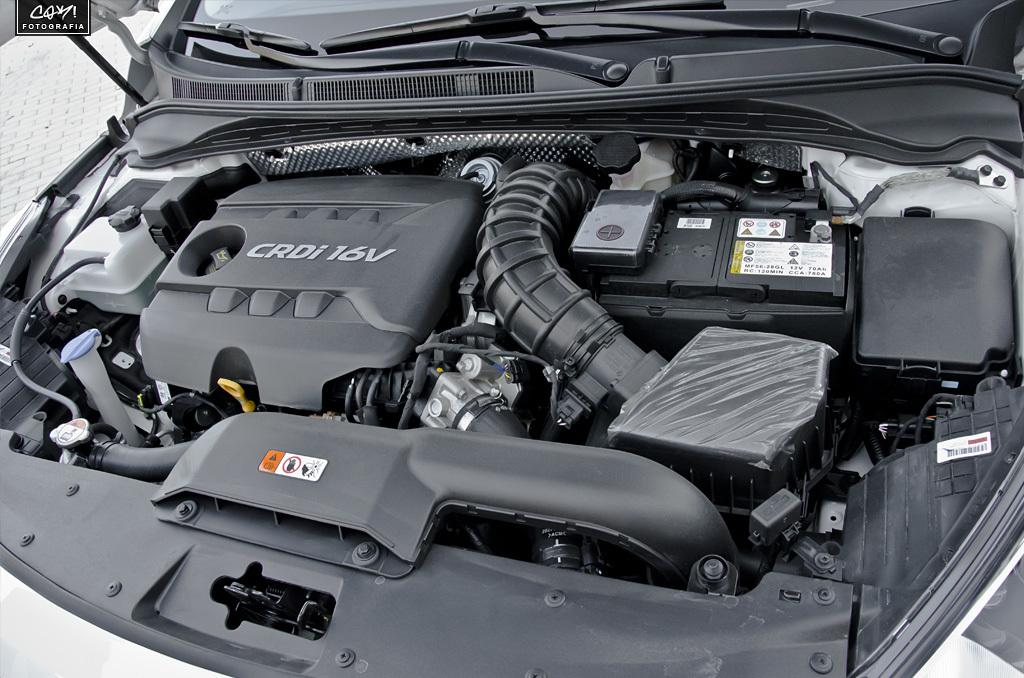What is the main subject of the image? The main subject of the image is an engine part of a car. How many lizards can be seen playing in the tramp in the image? There are no lizards or tramp present in the image; it features an engine part of a car. 